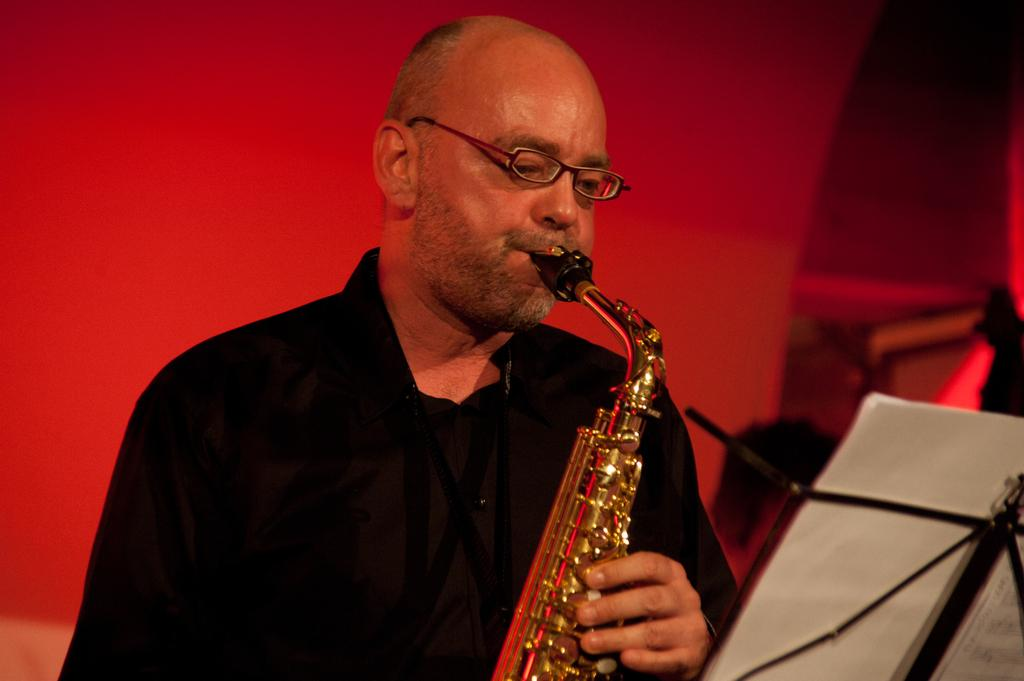What is the main subject of the image? There is a person playing a musical instrument in the image. What object is in front of the person? There is a book with a stand in front of the person. What color is the background of the image? The background of the image is red. What type of protest is happening in the background of the image? There is no protest visible in the image; the background is simply red. What specific detail can be seen on the musical instrument being played? The provided facts do not mention any specific details about the musical instrument, so we cannot answer this question definitively. 